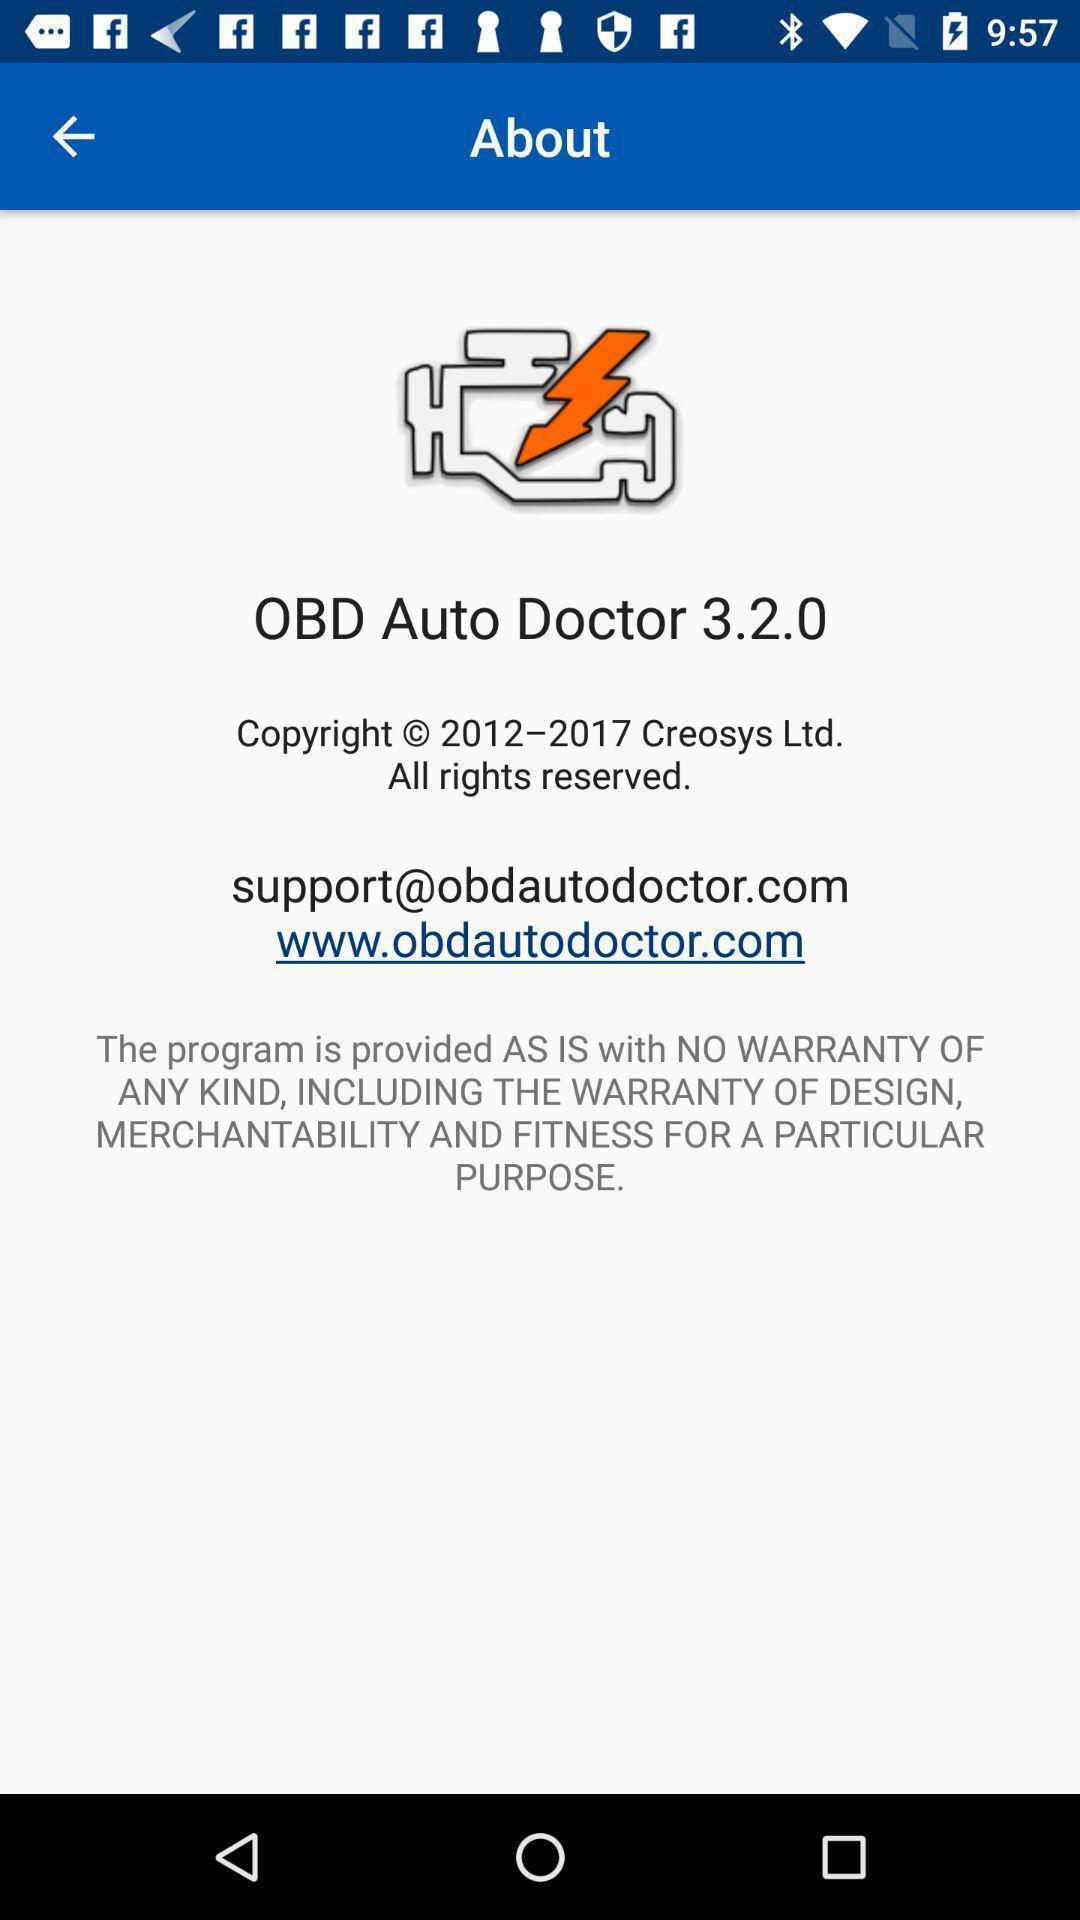What details can you identify in this image? Page showing information about an app. 